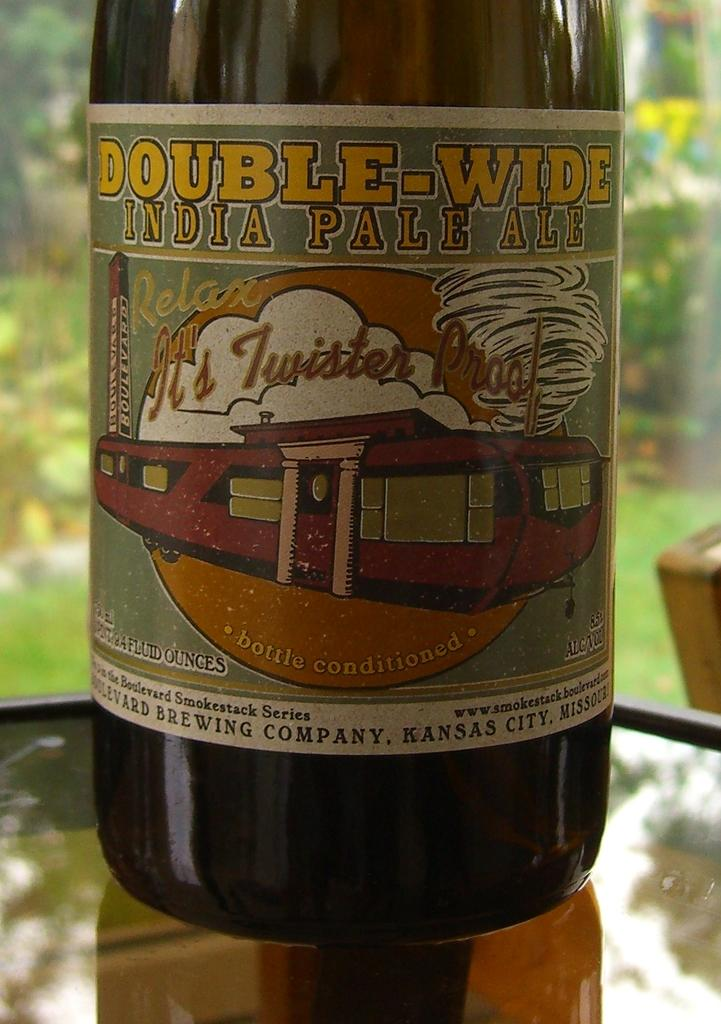Provide a one-sentence caption for the provided image. A bottle of Double-Wide IPA has a mobile home on the label. 